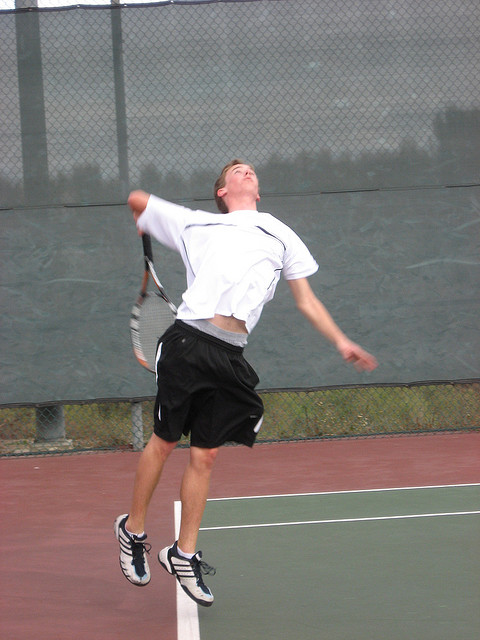<image>What brand is the racquet? It's not clear what brand the racquet is. It could be Wilson, Spalding, Babolat, or Dunlop. What brand is the racquet? It is unclear what brand the racquet is. It can be seen as Wilson, Spalding, or Babolat. 